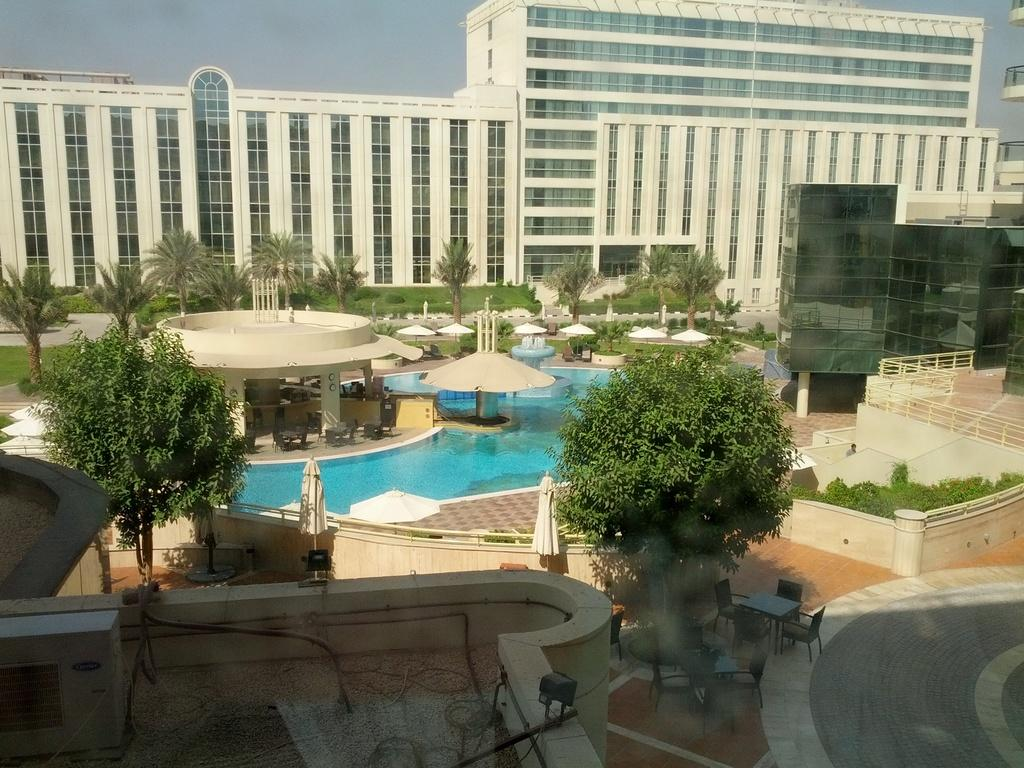What type of structure can be seen in the image? There is a building in the image. What natural elements are present in the image? There are trees, water, and grass visible in the image. What type of furniture is in the image? There are chairs and a table in the image. What type of vegetation is present in the image? There are plants and trees in the image. What part of the natural environment is visible in the image? The sky is visible in the image. What additional structure is present in the image? There is a shack in the image. Can you describe the snake that is slithering across the table in the image? There is no snake present in the image; the table is empty. What type of surprise can be seen in the image? There is no surprise depicted in the image; it shows a building, trees, a table, chairs, plants, water, a shack, and grass. 